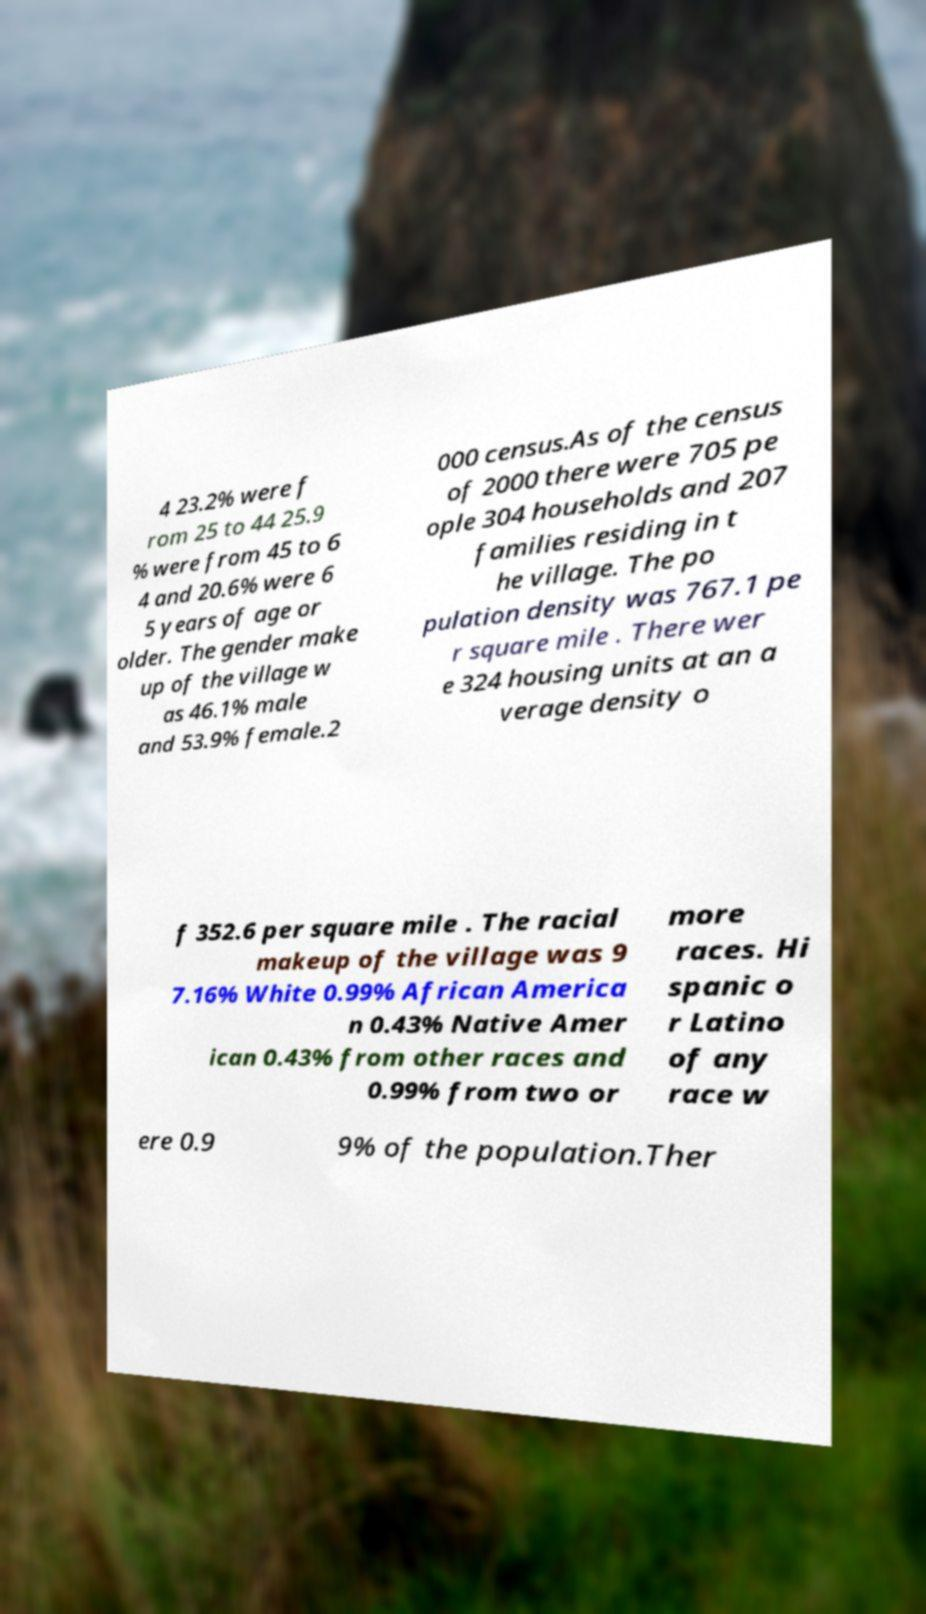Please read and relay the text visible in this image. What does it say? 4 23.2% were f rom 25 to 44 25.9 % were from 45 to 6 4 and 20.6% were 6 5 years of age or older. The gender make up of the village w as 46.1% male and 53.9% female.2 000 census.As of the census of 2000 there were 705 pe ople 304 households and 207 families residing in t he village. The po pulation density was 767.1 pe r square mile . There wer e 324 housing units at an a verage density o f 352.6 per square mile . The racial makeup of the village was 9 7.16% White 0.99% African America n 0.43% Native Amer ican 0.43% from other races and 0.99% from two or more races. Hi spanic o r Latino of any race w ere 0.9 9% of the population.Ther 